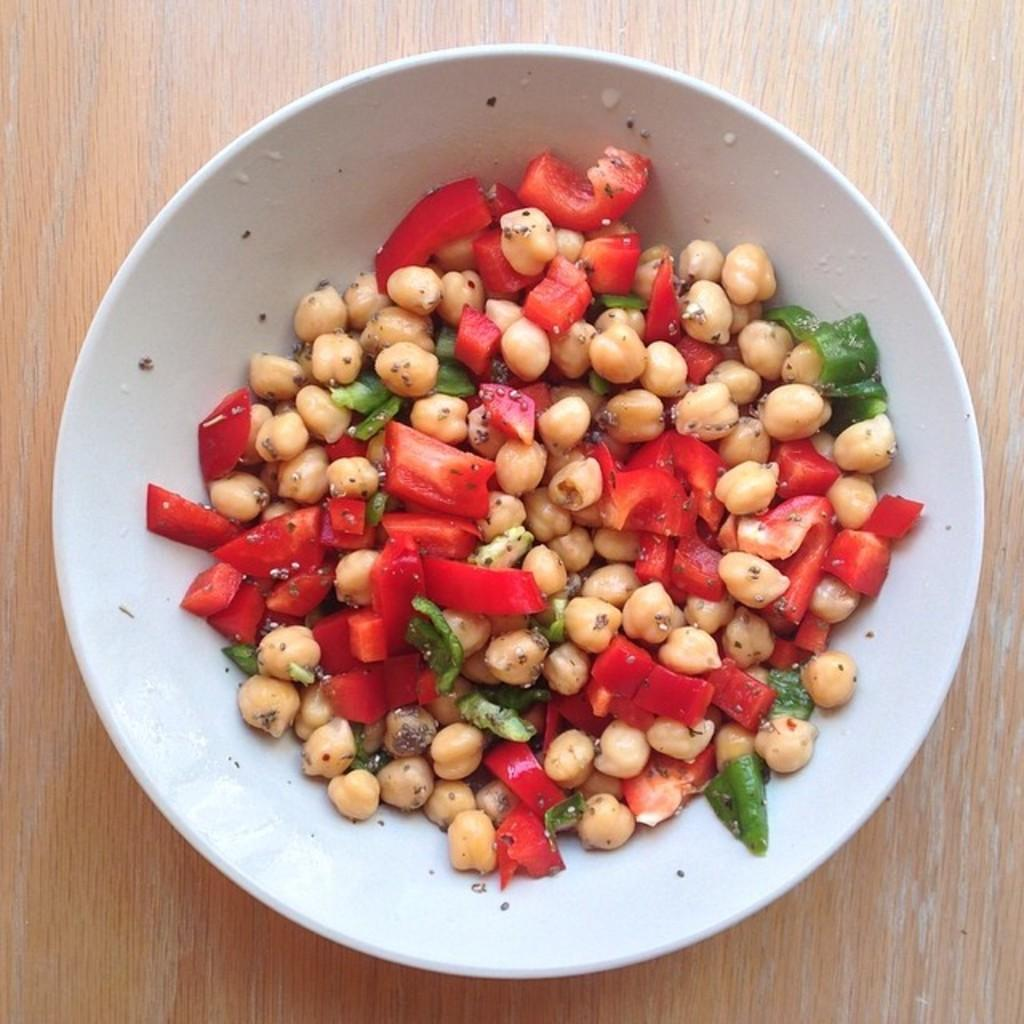What color is the bowl in the image? The bowl in the image is white. What is inside the bowl? There is food in the bowl. On what surface is the bowl placed? The bowl is placed on a wooden object. What type of stage can be seen in the background of the image? There is no stage present in the image. 